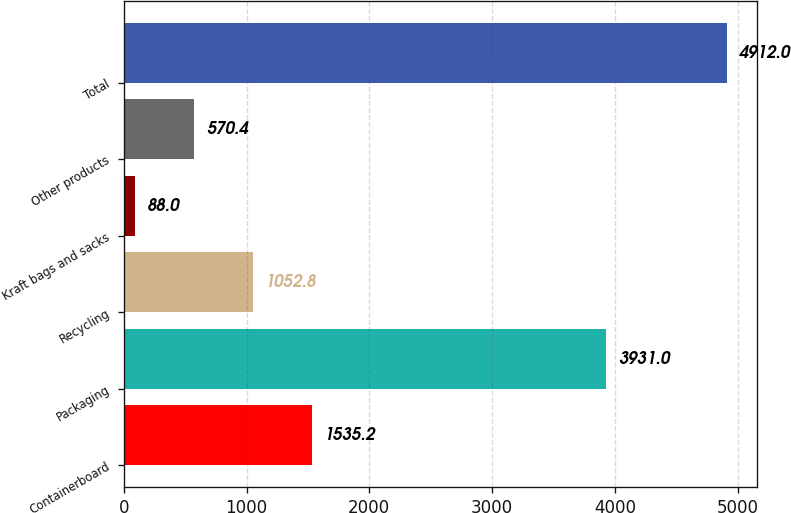<chart> <loc_0><loc_0><loc_500><loc_500><bar_chart><fcel>Containerboard<fcel>Packaging<fcel>Recycling<fcel>Kraft bags and sacks<fcel>Other products<fcel>Total<nl><fcel>1535.2<fcel>3931<fcel>1052.8<fcel>88<fcel>570.4<fcel>4912<nl></chart> 